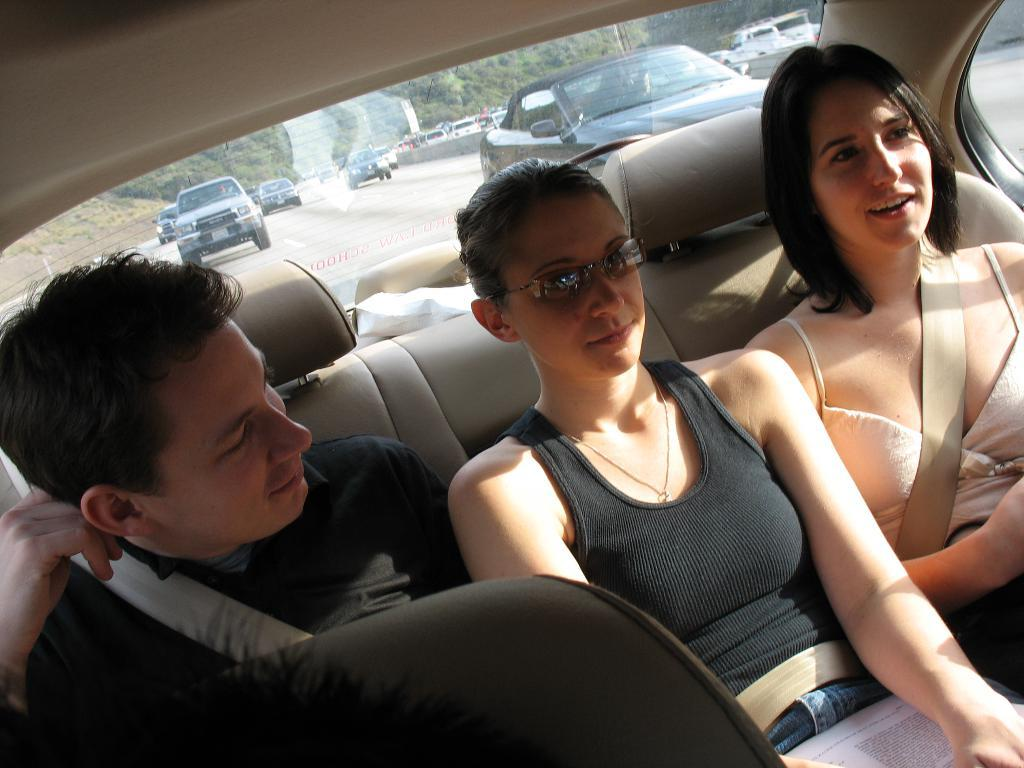What is happening in the image? There are people in a car in the image. Can you describe the setting of the image? The image shows a car with people inside, and there are vehicles visible on the road in the background. What type of eggs can be seen on the dashboard of the car in the image? There are no eggs visible in the image, as it only shows people in a car and vehicles on the road in the background. 